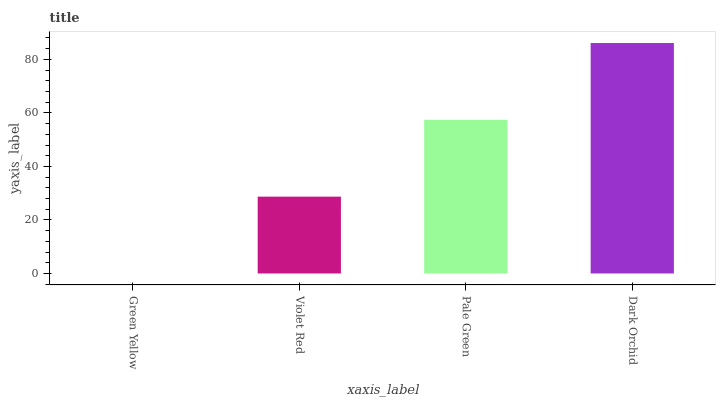Is Green Yellow the minimum?
Answer yes or no. Yes. Is Dark Orchid the maximum?
Answer yes or no. Yes. Is Violet Red the minimum?
Answer yes or no. No. Is Violet Red the maximum?
Answer yes or no. No. Is Violet Red greater than Green Yellow?
Answer yes or no. Yes. Is Green Yellow less than Violet Red?
Answer yes or no. Yes. Is Green Yellow greater than Violet Red?
Answer yes or no. No. Is Violet Red less than Green Yellow?
Answer yes or no. No. Is Pale Green the high median?
Answer yes or no. Yes. Is Violet Red the low median?
Answer yes or no. Yes. Is Dark Orchid the high median?
Answer yes or no. No. Is Pale Green the low median?
Answer yes or no. No. 